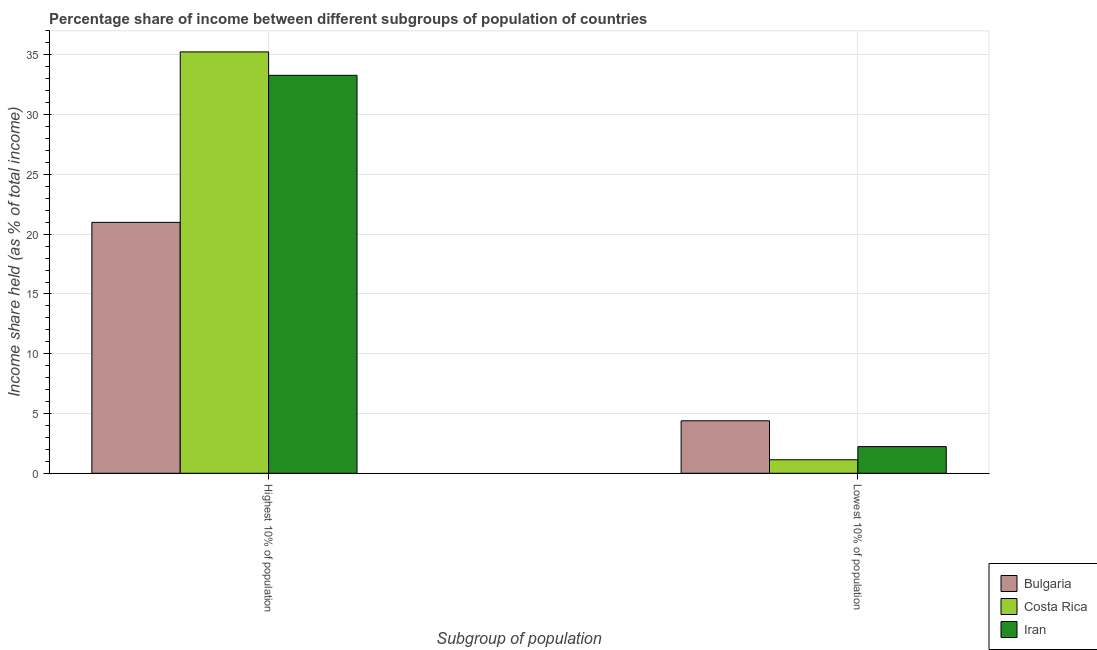How many groups of bars are there?
Keep it short and to the point. 2. How many bars are there on the 1st tick from the left?
Offer a very short reply. 3. How many bars are there on the 2nd tick from the right?
Your answer should be compact. 3. What is the label of the 1st group of bars from the left?
Provide a short and direct response. Highest 10% of population. What is the income share held by highest 10% of the population in Iran?
Ensure brevity in your answer.  33.29. Across all countries, what is the maximum income share held by highest 10% of the population?
Offer a very short reply. 35.25. Across all countries, what is the minimum income share held by lowest 10% of the population?
Ensure brevity in your answer.  1.13. In which country was the income share held by highest 10% of the population minimum?
Provide a succinct answer. Bulgaria. What is the total income share held by highest 10% of the population in the graph?
Offer a very short reply. 89.53. What is the difference between the income share held by lowest 10% of the population in Costa Rica and that in Iran?
Offer a terse response. -1.1. What is the difference between the income share held by lowest 10% of the population in Bulgaria and the income share held by highest 10% of the population in Costa Rica?
Your answer should be compact. -30.86. What is the average income share held by highest 10% of the population per country?
Provide a short and direct response. 29.84. What is the difference between the income share held by lowest 10% of the population and income share held by highest 10% of the population in Costa Rica?
Your response must be concise. -34.12. In how many countries, is the income share held by highest 10% of the population greater than 22 %?
Your answer should be very brief. 2. What is the ratio of the income share held by highest 10% of the population in Costa Rica to that in Iran?
Your answer should be compact. 1.06. How many bars are there?
Your answer should be compact. 6. Are all the bars in the graph horizontal?
Your response must be concise. No. Where does the legend appear in the graph?
Your answer should be compact. Bottom right. How are the legend labels stacked?
Offer a very short reply. Vertical. What is the title of the graph?
Provide a succinct answer. Percentage share of income between different subgroups of population of countries. Does "Bangladesh" appear as one of the legend labels in the graph?
Ensure brevity in your answer.  No. What is the label or title of the X-axis?
Your answer should be very brief. Subgroup of population. What is the label or title of the Y-axis?
Your response must be concise. Income share held (as % of total income). What is the Income share held (as % of total income) in Bulgaria in Highest 10% of population?
Your answer should be very brief. 20.99. What is the Income share held (as % of total income) in Costa Rica in Highest 10% of population?
Provide a succinct answer. 35.25. What is the Income share held (as % of total income) in Iran in Highest 10% of population?
Ensure brevity in your answer.  33.29. What is the Income share held (as % of total income) of Bulgaria in Lowest 10% of population?
Provide a short and direct response. 4.39. What is the Income share held (as % of total income) in Costa Rica in Lowest 10% of population?
Keep it short and to the point. 1.13. What is the Income share held (as % of total income) of Iran in Lowest 10% of population?
Make the answer very short. 2.23. Across all Subgroup of population, what is the maximum Income share held (as % of total income) of Bulgaria?
Ensure brevity in your answer.  20.99. Across all Subgroup of population, what is the maximum Income share held (as % of total income) in Costa Rica?
Provide a succinct answer. 35.25. Across all Subgroup of population, what is the maximum Income share held (as % of total income) in Iran?
Ensure brevity in your answer.  33.29. Across all Subgroup of population, what is the minimum Income share held (as % of total income) of Bulgaria?
Ensure brevity in your answer.  4.39. Across all Subgroup of population, what is the minimum Income share held (as % of total income) in Costa Rica?
Ensure brevity in your answer.  1.13. Across all Subgroup of population, what is the minimum Income share held (as % of total income) of Iran?
Provide a short and direct response. 2.23. What is the total Income share held (as % of total income) of Bulgaria in the graph?
Provide a succinct answer. 25.38. What is the total Income share held (as % of total income) of Costa Rica in the graph?
Provide a short and direct response. 36.38. What is the total Income share held (as % of total income) in Iran in the graph?
Ensure brevity in your answer.  35.52. What is the difference between the Income share held (as % of total income) of Costa Rica in Highest 10% of population and that in Lowest 10% of population?
Give a very brief answer. 34.12. What is the difference between the Income share held (as % of total income) of Iran in Highest 10% of population and that in Lowest 10% of population?
Your response must be concise. 31.06. What is the difference between the Income share held (as % of total income) in Bulgaria in Highest 10% of population and the Income share held (as % of total income) in Costa Rica in Lowest 10% of population?
Provide a succinct answer. 19.86. What is the difference between the Income share held (as % of total income) of Bulgaria in Highest 10% of population and the Income share held (as % of total income) of Iran in Lowest 10% of population?
Ensure brevity in your answer.  18.76. What is the difference between the Income share held (as % of total income) of Costa Rica in Highest 10% of population and the Income share held (as % of total income) of Iran in Lowest 10% of population?
Offer a terse response. 33.02. What is the average Income share held (as % of total income) of Bulgaria per Subgroup of population?
Your response must be concise. 12.69. What is the average Income share held (as % of total income) in Costa Rica per Subgroup of population?
Offer a very short reply. 18.19. What is the average Income share held (as % of total income) of Iran per Subgroup of population?
Your response must be concise. 17.76. What is the difference between the Income share held (as % of total income) in Bulgaria and Income share held (as % of total income) in Costa Rica in Highest 10% of population?
Your answer should be very brief. -14.26. What is the difference between the Income share held (as % of total income) of Costa Rica and Income share held (as % of total income) of Iran in Highest 10% of population?
Your answer should be compact. 1.96. What is the difference between the Income share held (as % of total income) in Bulgaria and Income share held (as % of total income) in Costa Rica in Lowest 10% of population?
Your answer should be very brief. 3.26. What is the difference between the Income share held (as % of total income) of Bulgaria and Income share held (as % of total income) of Iran in Lowest 10% of population?
Your answer should be compact. 2.16. What is the ratio of the Income share held (as % of total income) of Bulgaria in Highest 10% of population to that in Lowest 10% of population?
Make the answer very short. 4.78. What is the ratio of the Income share held (as % of total income) in Costa Rica in Highest 10% of population to that in Lowest 10% of population?
Provide a succinct answer. 31.19. What is the ratio of the Income share held (as % of total income) of Iran in Highest 10% of population to that in Lowest 10% of population?
Keep it short and to the point. 14.93. What is the difference between the highest and the second highest Income share held (as % of total income) in Costa Rica?
Your response must be concise. 34.12. What is the difference between the highest and the second highest Income share held (as % of total income) in Iran?
Give a very brief answer. 31.06. What is the difference between the highest and the lowest Income share held (as % of total income) of Costa Rica?
Offer a terse response. 34.12. What is the difference between the highest and the lowest Income share held (as % of total income) of Iran?
Provide a succinct answer. 31.06. 